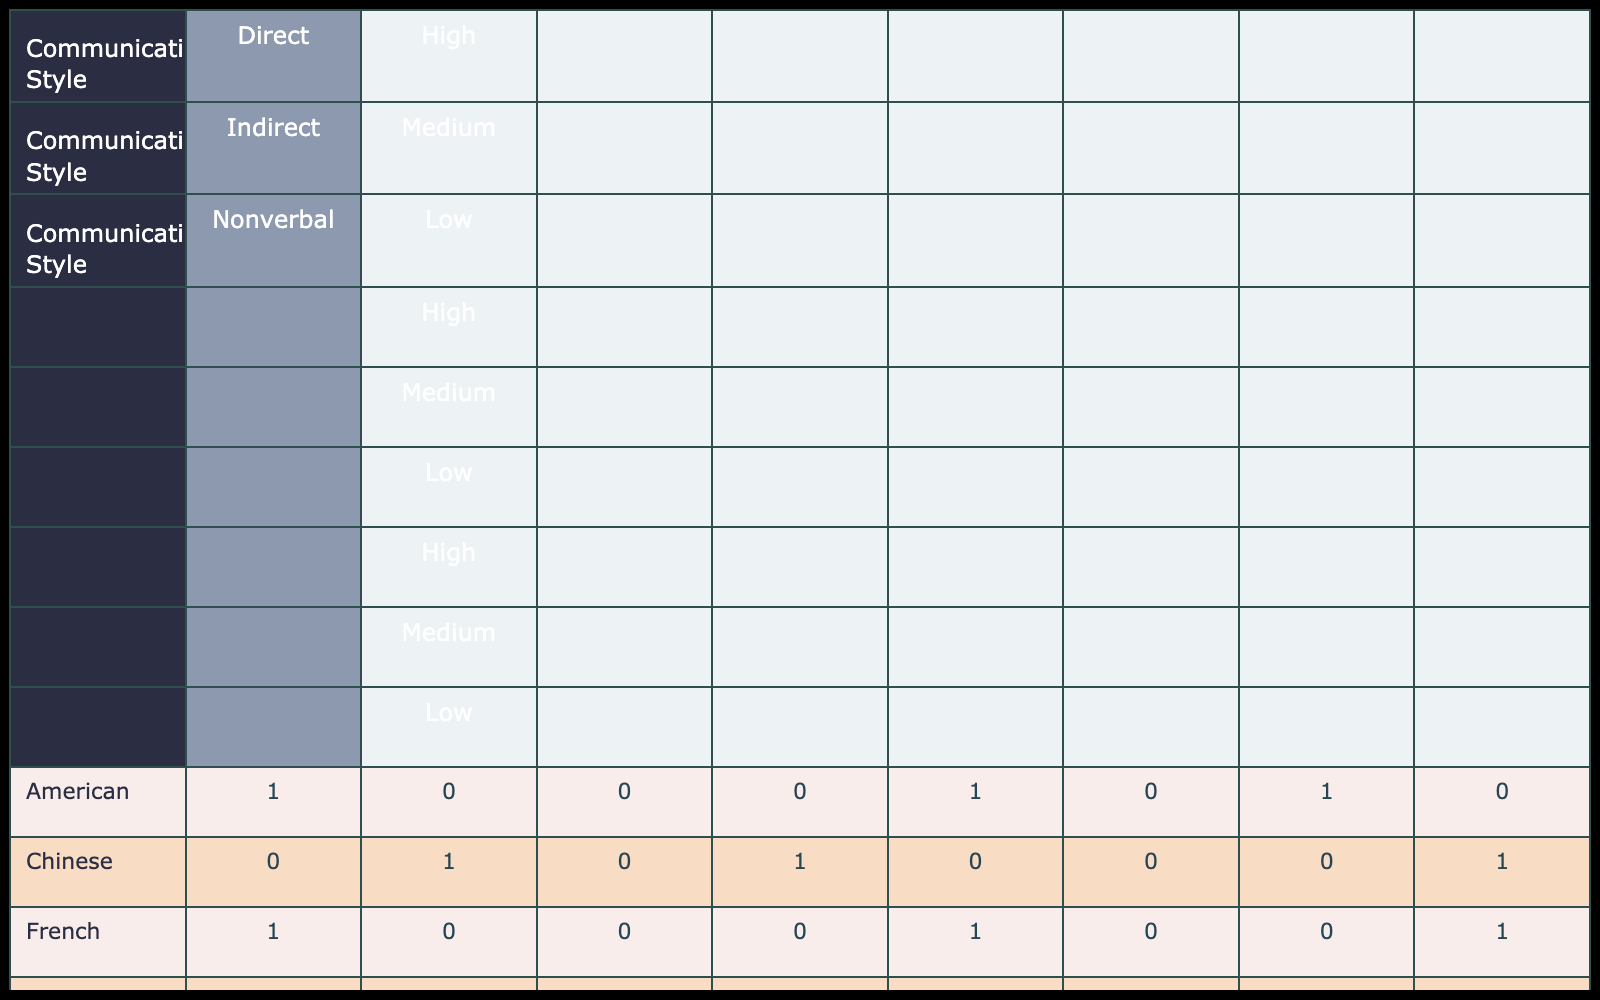What satisfaction level do Japanese individuals report for their indirect communication style? According to the table, Japanese individuals report a "High" satisfaction level with their indirect communication style, as indicated in the corresponding cell.
Answer: High How many different satisfaction levels are reported for the direct communication style across all cultural backgrounds? By checking the direct communication style for each cultural background, we find the following satisfaction levels: High for American, Japanese, German, and French; Medium for Mexican and Indian; Low for Chinese. Thus, there are three different satisfaction levels: High, Medium, and Low.
Answer: Three Is it true that all cultural backgrounds report at least one high satisfaction level for nonverbal communication? Analyzing the nonverbal communication satisfaction levels: Japanese (High), German (Medium), Mexican (High), Chinese (Medium), and Indian (High) indicate that not all cultural backgrounds report a high level, as Germans and Chinese reported Medium.
Answer: No What is the total number of individuals reporting a medium satisfaction level across all cultural backgrounds and communication styles? By reviewing the table: Americans (1), Germans (2), Mexicans (1), Indians (2) report medium for direct; Americans (1), Germans (1), French (1) report medium for indirect; German (1), Chinese (1) report medium for nonverbal. Thus, the total is 1 + 2 + 1 + 2 + 1 + 1 = 8.
Answer: 8 Among all cultural backgrounds, which communication style has the highest count of low satisfaction levels? The direct communication style reports a low satisfaction level only for Chinese individuals. Each of the other communication styles has different distributions, hence direct communication has the highest low counts as it is the only one with that satisfaction level.
Answer: Direct communication style 